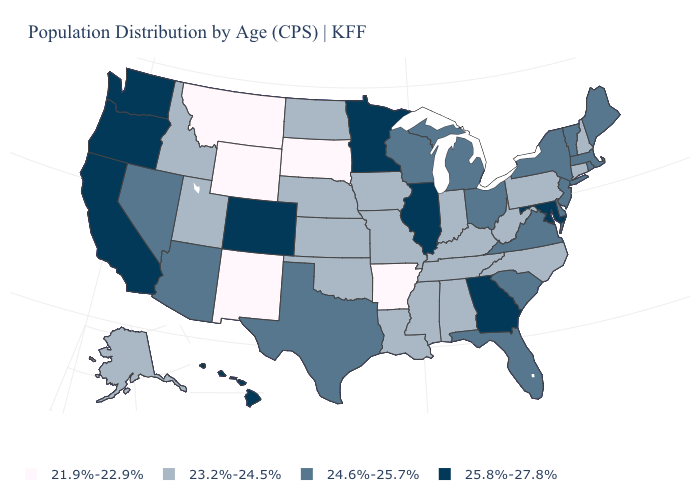What is the value of Alaska?
Give a very brief answer. 23.2%-24.5%. Does California have the same value as Georgia?
Quick response, please. Yes. Name the states that have a value in the range 23.2%-24.5%?
Give a very brief answer. Alabama, Alaska, Connecticut, Idaho, Indiana, Iowa, Kansas, Kentucky, Louisiana, Mississippi, Missouri, Nebraska, New Hampshire, North Carolina, North Dakota, Oklahoma, Pennsylvania, Tennessee, Utah, West Virginia. Among the states that border Oregon , does California have the highest value?
Quick response, please. Yes. Name the states that have a value in the range 25.8%-27.8%?
Write a very short answer. California, Colorado, Georgia, Hawaii, Illinois, Maryland, Minnesota, Oregon, Washington. What is the value of Louisiana?
Concise answer only. 23.2%-24.5%. Name the states that have a value in the range 25.8%-27.8%?
Quick response, please. California, Colorado, Georgia, Hawaii, Illinois, Maryland, Minnesota, Oregon, Washington. Which states have the lowest value in the West?
Give a very brief answer. Montana, New Mexico, Wyoming. What is the highest value in the USA?
Write a very short answer. 25.8%-27.8%. Among the states that border New Mexico , which have the highest value?
Be succinct. Colorado. What is the value of Montana?
Keep it brief. 21.9%-22.9%. What is the highest value in the South ?
Answer briefly. 25.8%-27.8%. What is the value of West Virginia?
Write a very short answer. 23.2%-24.5%. Among the states that border Kentucky , does Illinois have the highest value?
Concise answer only. Yes. Does North Dakota have the same value as Pennsylvania?
Short answer required. Yes. 